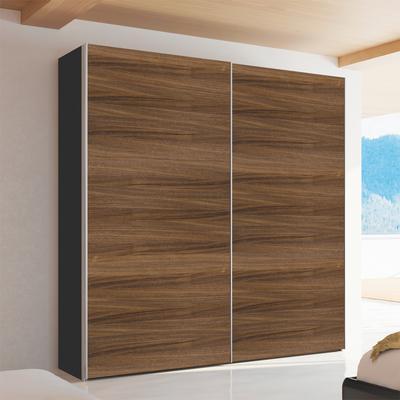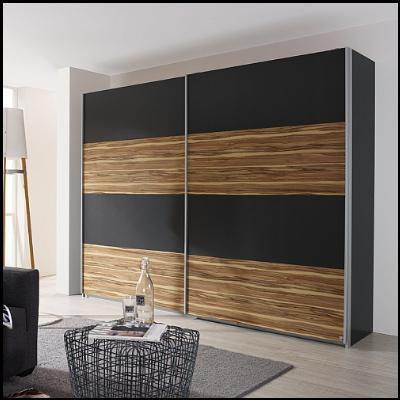The first image is the image on the left, the second image is the image on the right. Analyze the images presented: Is the assertion "There are four black panels on the wooden closet in the image on the right." valid? Answer yes or no. Yes. The first image is the image on the left, the second image is the image on the right. Assess this claim about the two images: "Two wardrobes are each divided vertically down the middle to accommodate equal size solid doors.". Correct or not? Answer yes or no. Yes. 